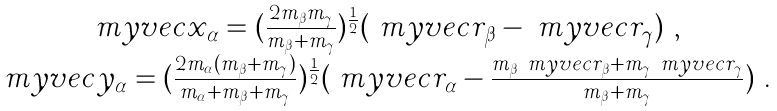Convert formula to latex. <formula><loc_0><loc_0><loc_500><loc_500>\begin{array} { c } \ m y v e c { x } _ { \alpha } = ( \frac { 2 m _ { \beta } m _ { \gamma } } { m _ { \beta } + m _ { \gamma } } ) ^ { \frac { 1 } { 2 } } ( \ m y v e c { r } _ { \beta } - \ m y v e c { r } _ { \gamma } ) \ , \\ \ m y v e c { y } _ { \alpha } = ( \frac { 2 m _ { \alpha } ( m _ { \beta } + m _ { \gamma } ) } { m _ { \alpha } + m _ { \beta } + m _ { \gamma } } ) ^ { \frac { 1 } { 2 } } ( \ m y v e c { r } _ { \alpha } - \frac { m _ { \beta } \ m y v e c { r } _ { \beta } + m _ { \gamma } \ m y v e c { r } _ { \gamma } } { m _ { \beta } + m _ { \gamma } } ) \ . \end{array}</formula> 